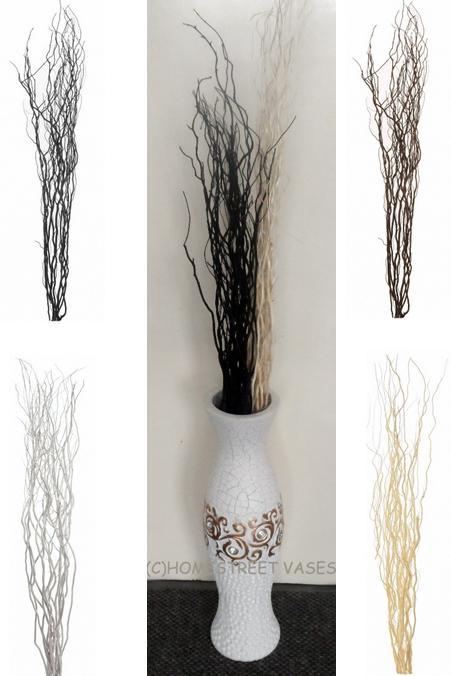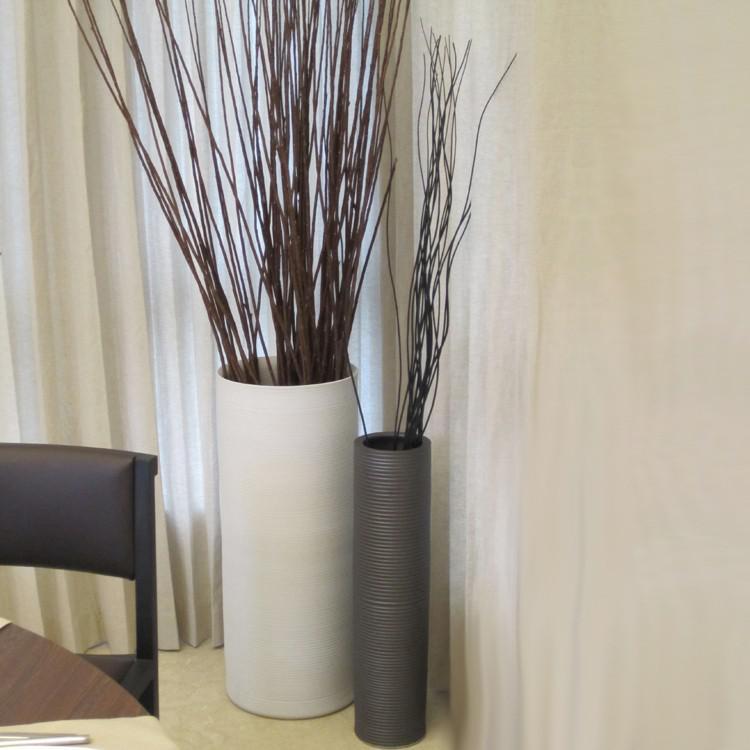The first image is the image on the left, the second image is the image on the right. Considering the images on both sides, is "there is one vase on the right image" valid? Answer yes or no. No. 